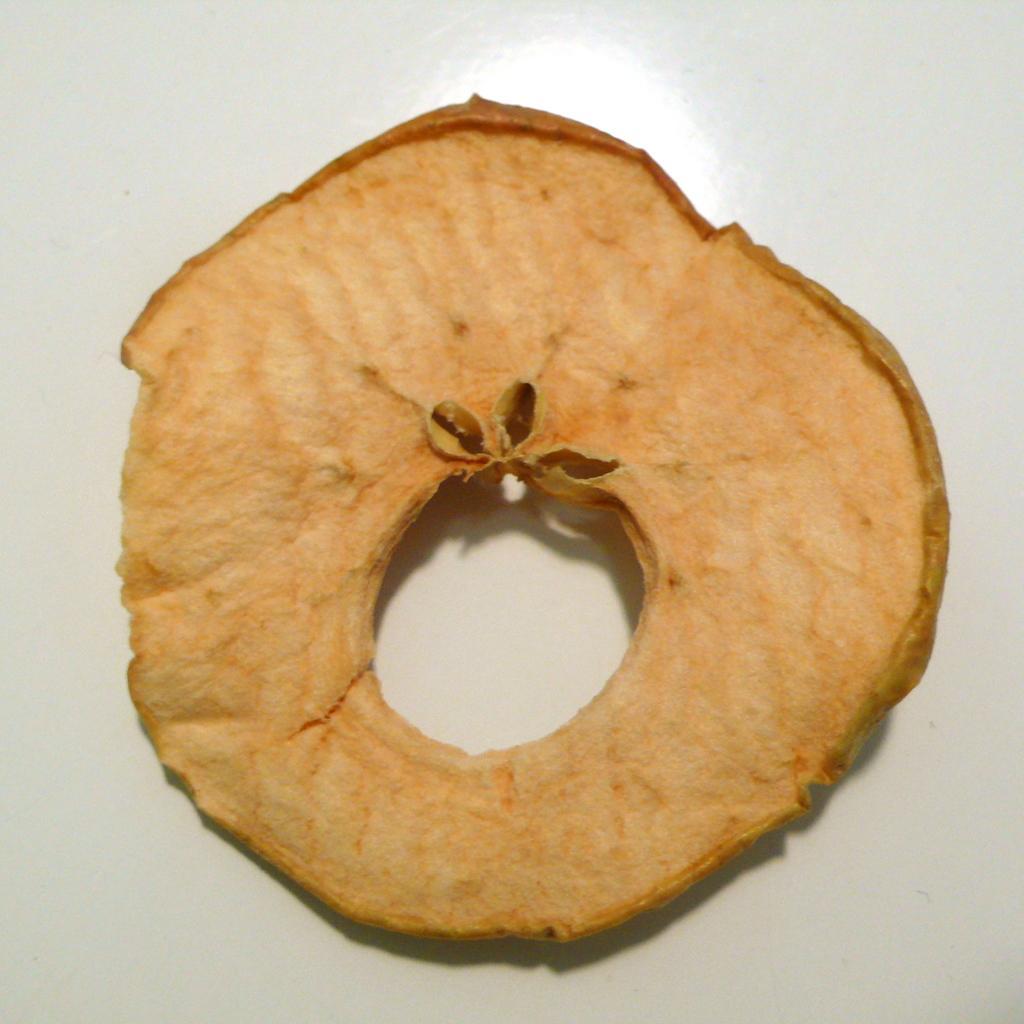Describe this image in one or two sentences. In this image there is a slice of a fruit with seeds. 